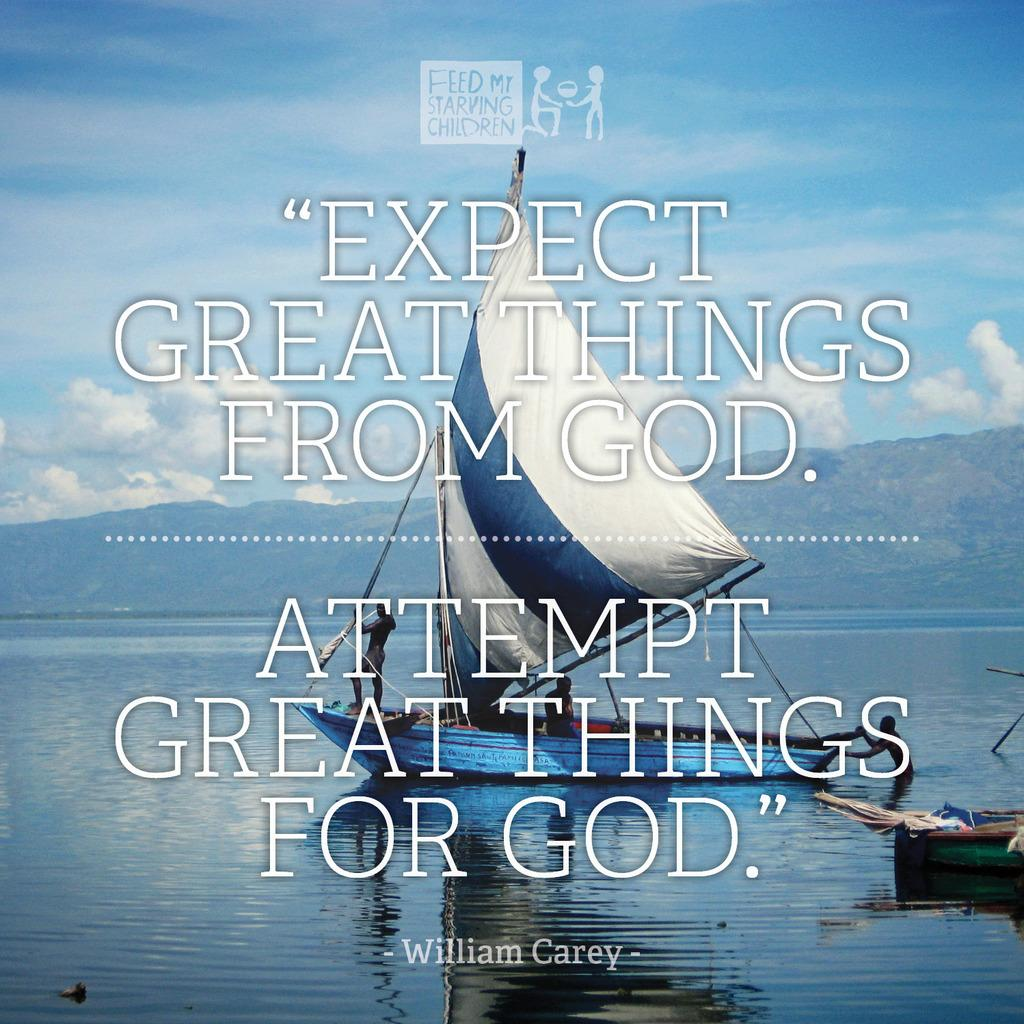<image>
Provide a brief description of the given image. Poster with a ship in the back and the phrase "Expect great things from God". 